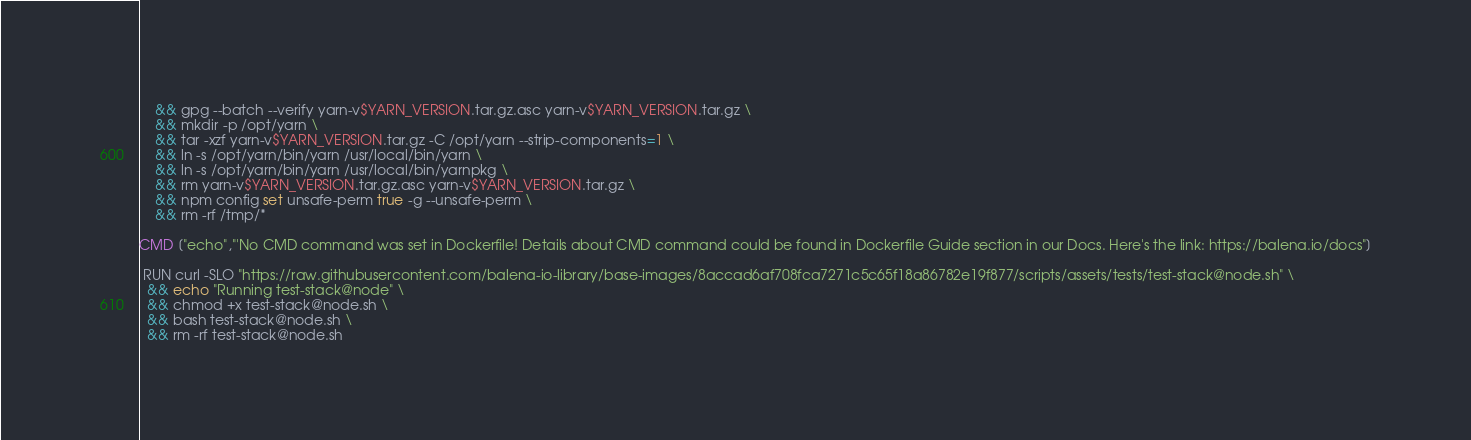Convert code to text. <code><loc_0><loc_0><loc_500><loc_500><_Dockerfile_>	&& gpg --batch --verify yarn-v$YARN_VERSION.tar.gz.asc yarn-v$YARN_VERSION.tar.gz \
	&& mkdir -p /opt/yarn \
	&& tar -xzf yarn-v$YARN_VERSION.tar.gz -C /opt/yarn --strip-components=1 \
	&& ln -s /opt/yarn/bin/yarn /usr/local/bin/yarn \
	&& ln -s /opt/yarn/bin/yarn /usr/local/bin/yarnpkg \
	&& rm yarn-v$YARN_VERSION.tar.gz.asc yarn-v$YARN_VERSION.tar.gz \
	&& npm config set unsafe-perm true -g --unsafe-perm \
	&& rm -rf /tmp/*

CMD ["echo","'No CMD command was set in Dockerfile! Details about CMD command could be found in Dockerfile Guide section in our Docs. Here's the link: https://balena.io/docs"]

 RUN curl -SLO "https://raw.githubusercontent.com/balena-io-library/base-images/8accad6af708fca7271c5c65f18a86782e19f877/scripts/assets/tests/test-stack@node.sh" \
  && echo "Running test-stack@node" \
  && chmod +x test-stack@node.sh \
  && bash test-stack@node.sh \
  && rm -rf test-stack@node.sh 
</code> 